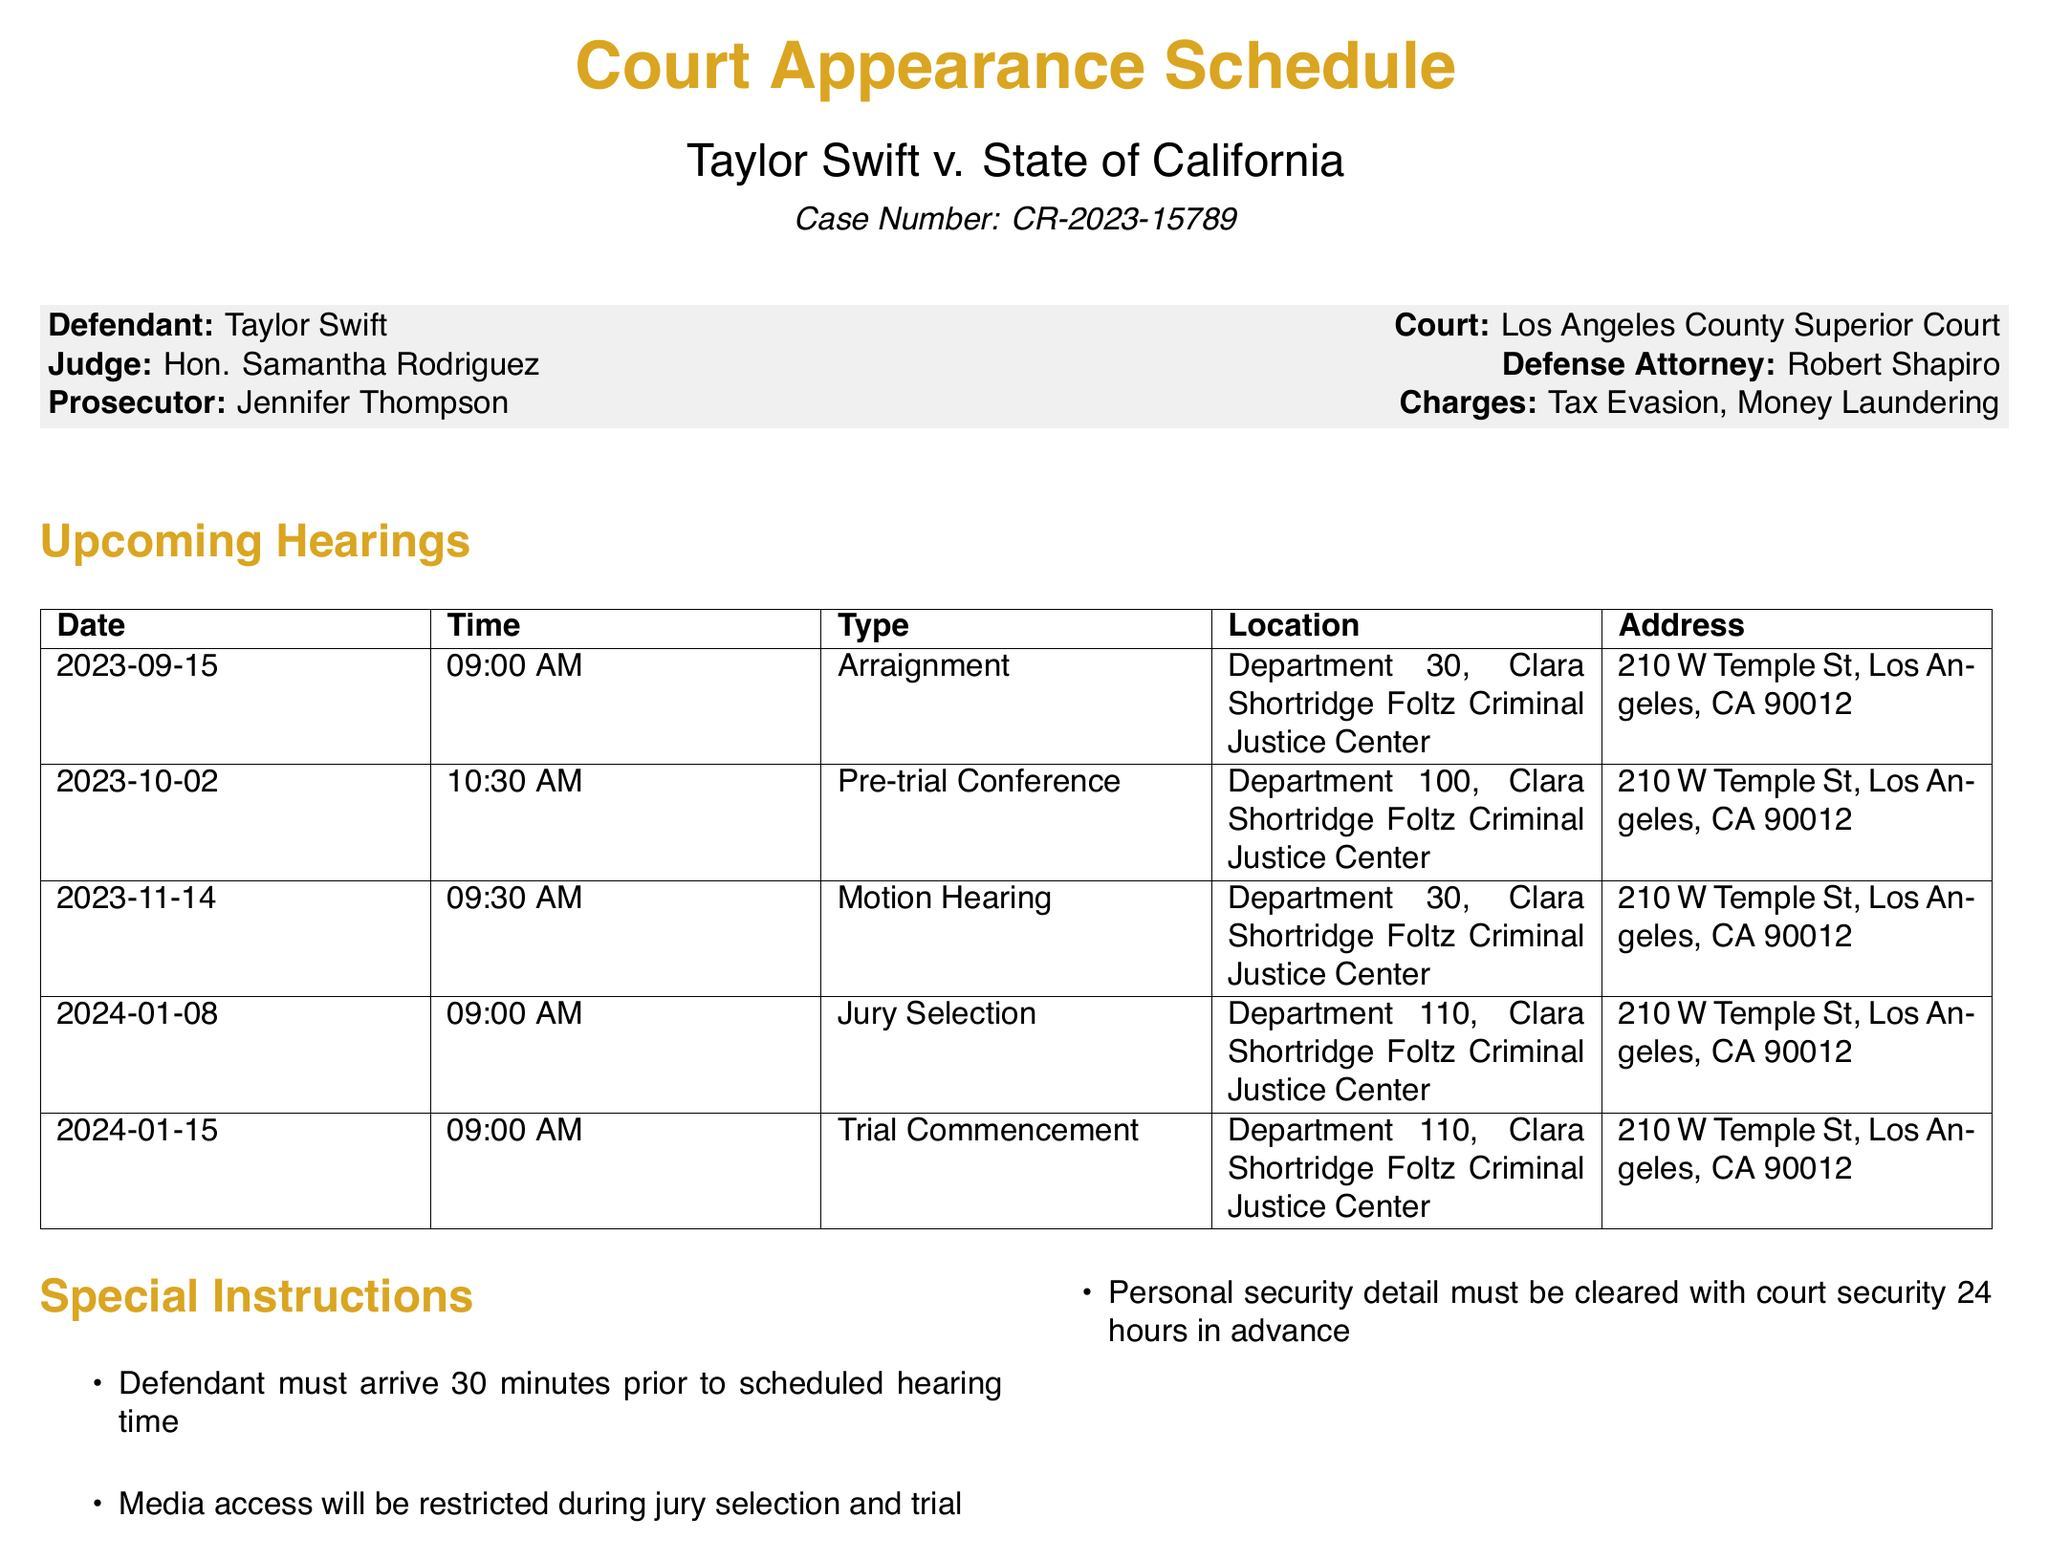What is the defendant's name? The defendant's name is stated at the beginning of the document.
Answer: Taylor Swift What is the case number? The case number is clearly labeled in the document.
Answer: CR-2023-15789 Who is the judge presiding over the case? The judge's name is specified in the court details.
Answer: Hon. Samantha Rodriguez What is the date of the next hearing? The next upcoming hearing date is the first listed in the schedule.
Answer: 2023-09-15 What type of hearing is scheduled on October 2nd? This question requires combining the date with the type of hearing from the schedule.
Answer: Pre-trial Conference Where is the trial commencement scheduled to occur? The location for the trial commencement is mentioned under upcoming hearings.
Answer: Department 110, Clara Shortridge Foltz Criminal Justice Center How many conditions are listed under bail conditions? The number of conditions can be counted from the bail conditions section.
Answer: 3 What attire is required in the courtroom? This is explained under courtroom rules.
Answer: Professional attire required When must the defendant arrive prior to a hearing? This information is provided in the special instructions section of the document.
Answer: 30 minutes prior 